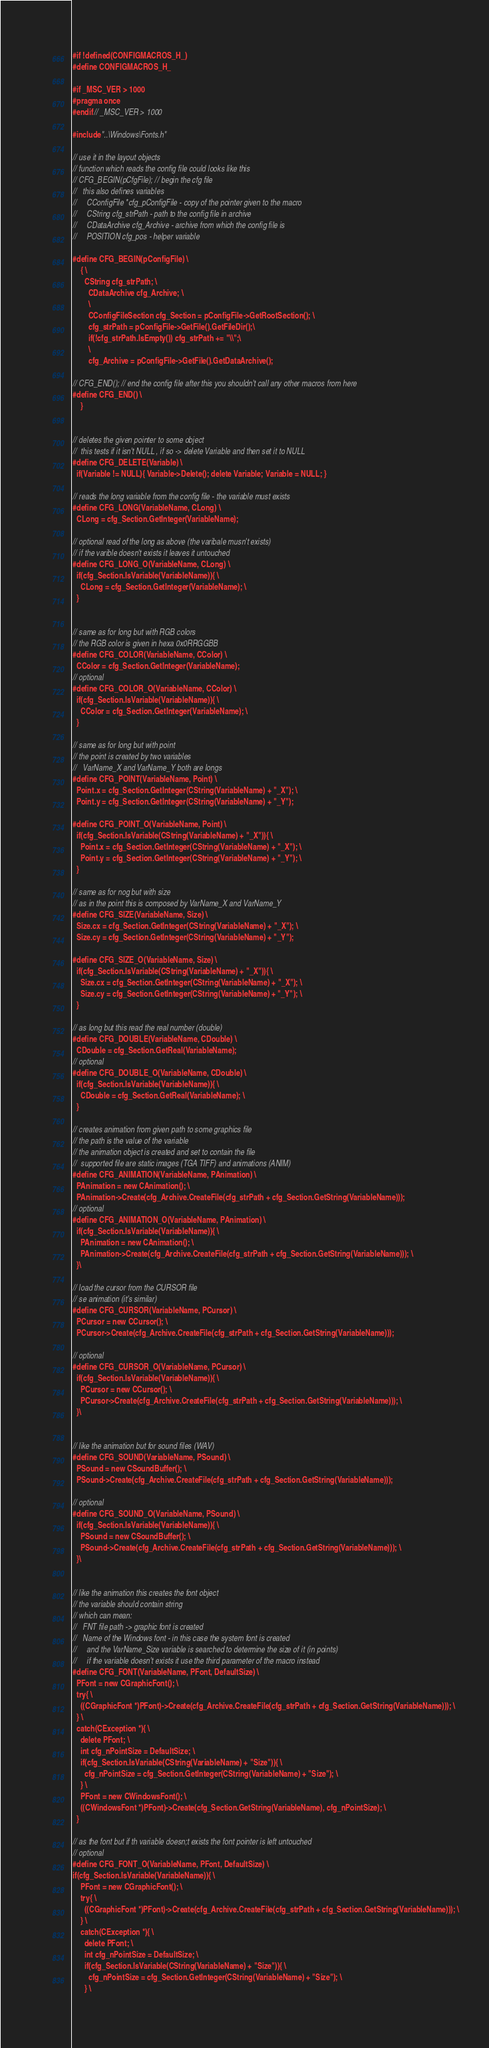Convert code to text. <code><loc_0><loc_0><loc_500><loc_500><_C_>#if !defined(CONFIGMACROS_H_)
#define CONFIGMACROS_H_

#if _MSC_VER > 1000
#pragma once
#endif // _MSC_VER > 1000

#include "..\Windows\Fonts.h"

// use it in the layout objects
// function which reads the config file could looks like this
// CFG_BEGIN(pCfgFile); // begin the cfg file 
//   this also defines variables
//     CConfigFile *cfg_pConfigFile - copy of the pointer given to the macro
//     CString cfg_strPath - path to the config file in archive
//     CDataArchive cfg_Archive - archive from which the config file is
//     POSITION cfg_pos - helper variable

#define CFG_BEGIN(pConfigFile) \
	{ \
	  CString cfg_strPath; \
		CDataArchive cfg_Archive; \
		\
		CConfigFileSection cfg_Section = pConfigFile->GetRootSection(); \
		cfg_strPath = pConfigFile->GetFile().GetFileDir();\
		if(!cfg_strPath.IsEmpty()) cfg_strPath += "\\";\
		\
		cfg_Archive = pConfigFile->GetFile().GetDataArchive();

// CFG_END(); // end the config file after this you shouldn't call any other macros from here
#define CFG_END() \
	}


// deletes the given pointer to some object
//  this tests if it isn't NULL , if so -> delete Variable and then set it to NULL
#define CFG_DELETE(Variable) \
  if(Variable != NULL){ Variable->Delete(); delete Variable; Variable = NULL; }

// reads the long variable from the config file - the variable must exists
#define CFG_LONG(VariableName, CLong) \
  CLong = cfg_Section.GetInteger(VariableName);

// optional read of the long as above (the varibale musn't exists)
// if the varible doesn't exists it leaves it untouched
#define CFG_LONG_O(VariableName, CLong) \
  if(cfg_Section.IsVariable(VariableName)){ \
    CLong = cfg_Section.GetInteger(VariableName); \
  }


// same as for long but with RGB colors
// the RGB color is given in hexa 0x0RRGGBB
#define CFG_COLOR(VariableName, CColor) \
  CColor = cfg_Section.GetInteger(VariableName);
// optional
#define CFG_COLOR_O(VariableName, CColor) \
  if(cfg_Section.IsVariable(VariableName)){ \
    CColor = cfg_Section.GetInteger(VariableName); \
  }

// same as for long but with point
// the point is created by two variables
//   VarName_X and VarName_Y both are longs
#define CFG_POINT(VariableName, Point) \
  Point.x = cfg_Section.GetInteger(CString(VariableName) + "_X"); \
  Point.y = cfg_Section.GetInteger(CString(VariableName) + "_Y");

#define CFG_POINT_O(VariableName, Point) \
  if(cfg_Section.IsVariable(CString(VariableName) + "_X")){ \
    Point.x = cfg_Section.GetInteger(CString(VariableName) + "_X"); \
    Point.y = cfg_Section.GetInteger(CString(VariableName) + "_Y"); \
  }

// same as for nog but with size
// as in the point this is composed by VarName_X and VarName_Y
#define CFG_SIZE(VariableName, Size) \
  Size.cx = cfg_Section.GetInteger(CString(VariableName) + "_X"); \
  Size.cy = cfg_Section.GetInteger(CString(VariableName) + "_Y");

#define CFG_SIZE_O(VariableName, Size) \
  if(cfg_Section.IsVariable(CString(VariableName) + "_X")){ \
    Size.cx = cfg_Section.GetInteger(CString(VariableName) + "_X"); \
    Size.cy = cfg_Section.GetInteger(CString(VariableName) + "_Y"); \
  }

// as long but this read the real number (double)
#define CFG_DOUBLE(VariableName, CDouble) \
  CDouble = cfg_Section.GetReal(VariableName);
// optional
#define CFG_DOUBLE_O(VariableName, CDouble) \
  if(cfg_Section.IsVariable(VariableName)){ \
    CDouble = cfg_Section.GetReal(VariableName); \
  }

// creates animation from given path to some graphics file
// the path is the value of the variable
// the animation object is created and set to contain the file
//  supported file are static images (TGA TIFF) and animations (ANIM)
#define CFG_ANIMATION(VariableName, PAnimation) \
  PAnimation = new CAnimation(); \
  PAnimation->Create(cfg_Archive.CreateFile(cfg_strPath + cfg_Section.GetString(VariableName)));
// optional
#define CFG_ANIMATION_O(VariableName, PAnimation) \
  if(cfg_Section.IsVariable(VariableName)){ \
    PAnimation = new CAnimation(); \
    PAnimation->Create(cfg_Archive.CreateFile(cfg_strPath + cfg_Section.GetString(VariableName))); \
  }\

// load the cursor from the CURSOR file
// se animation (it's similar)
#define CFG_CURSOR(VariableName, PCursor) \
  PCursor = new CCursor(); \
  PCursor->Create(cfg_Archive.CreateFile(cfg_strPath + cfg_Section.GetString(VariableName)));

// optional
#define CFG_CURSOR_O(VariableName, PCursor) \
  if(cfg_Section.IsVariable(VariableName)){ \
    PCursor = new CCursor(); \
    PCursor->Create(cfg_Archive.CreateFile(cfg_strPath + cfg_Section.GetString(VariableName))); \
  }\


// like the animation but for sound files (WAV)
#define CFG_SOUND(VariableName, PSound) \
  PSound = new CSoundBuffer(); \
  PSound->Create(cfg_Archive.CreateFile(cfg_strPath + cfg_Section.GetString(VariableName)));

// optional
#define CFG_SOUND_O(VariableName, PSound) \
  if(cfg_Section.IsVariable(VariableName)){ \
    PSound = new CSoundBuffer(); \
    PSound->Create(cfg_Archive.CreateFile(cfg_strPath + cfg_Section.GetString(VariableName))); \
  }\


// like the animation this creates the font object
// the variable should contain string
// which can mean:
//   FNT file path -> graphic font is created
//   Name of the Windows font - in this case the system font is created
//     and the VarName_Size variable is searched to determine the size of it (in points)
//     if the variable doesn't exists it use the third parameter of the macro instead
#define CFG_FONT(VariableName, PFont, DefaultSize) \
  PFont = new CGraphicFont(); \
  try{ \
    ((CGraphicFont *)PFont)->Create(cfg_Archive.CreateFile(cfg_strPath + cfg_Section.GetString(VariableName))); \
  } \
  catch(CException *){ \
    delete PFont; \
    int cfg_nPointSize = DefaultSize; \
    if(cfg_Section.IsVariable(CString(VariableName) + "Size")){ \
      cfg_nPointSize = cfg_Section.GetInteger(CString(VariableName) + "Size"); \
    } \
    PFont = new CWindowsFont(); \
    ((CWindowsFont *)PFont)->Create(cfg_Section.GetString(VariableName), cfg_nPointSize); \
  }

// as the font but if th variable doesn;t exists the font pointer is left untouched
// optional
#define CFG_FONT_O(VariableName, PFont, DefaultSize) \
if(cfg_Section.IsVariable(VariableName)){ \
    PFont = new CGraphicFont(); \
    try{ \
      ((CGraphicFont *)PFont)->Create(cfg_Archive.CreateFile(cfg_strPath + cfg_Section.GetString(VariableName))); \
    } \
    catch(CException *){ \
      delete PFont; \
      int cfg_nPointSize = DefaultSize; \
      if(cfg_Section.IsVariable(CString(VariableName) + "Size")){ \
        cfg_nPointSize = cfg_Section.GetInteger(CString(VariableName) + "Size"); \
      } \</code> 